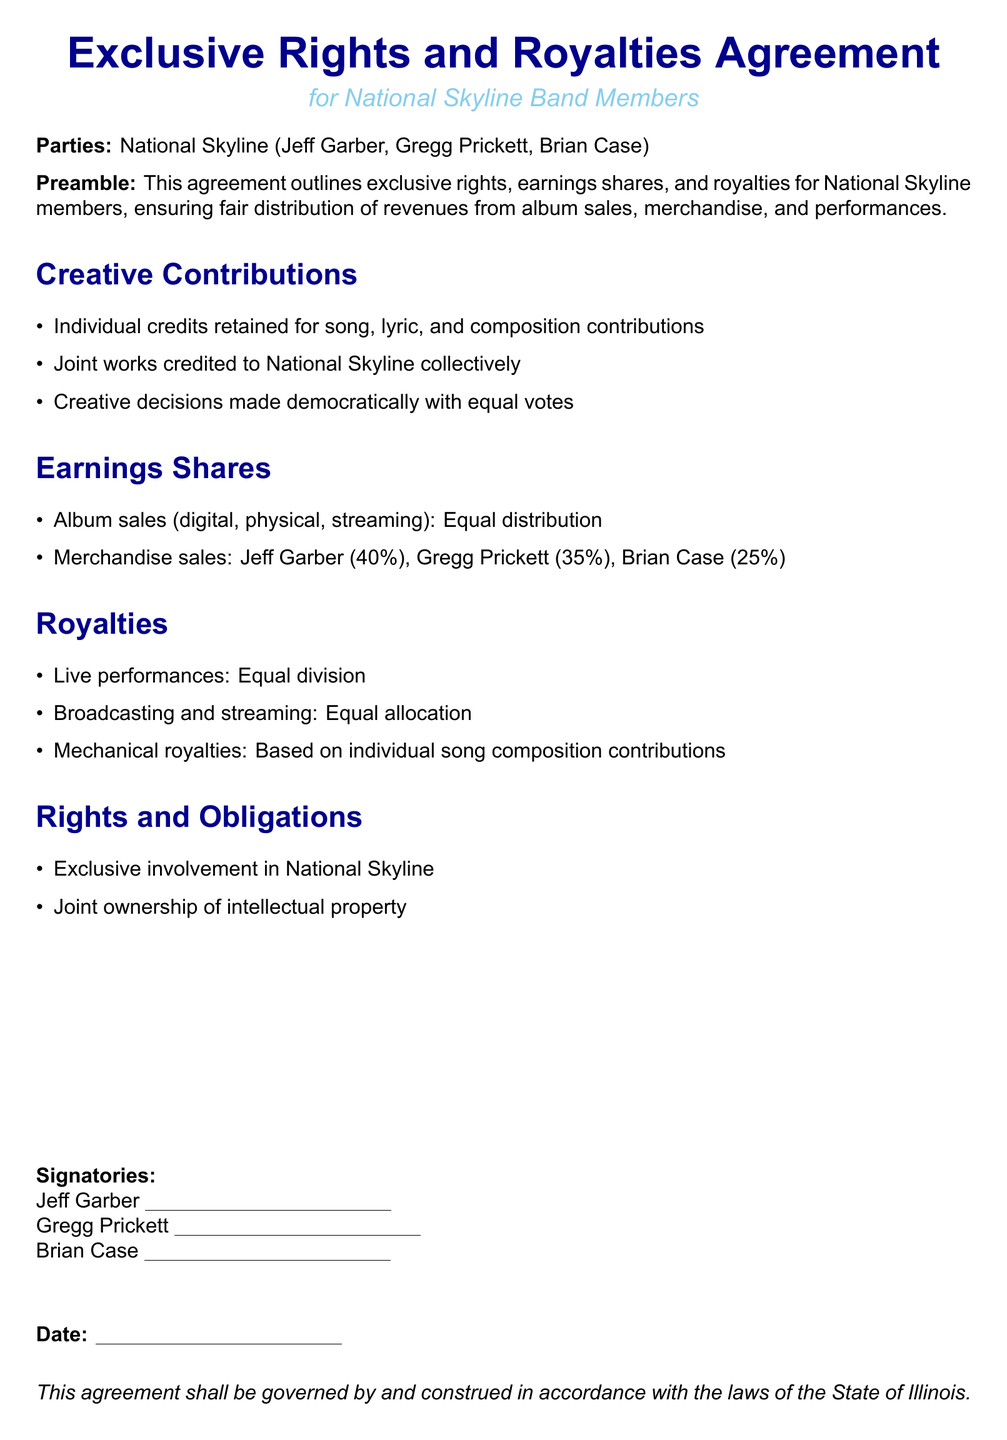What is the primary focus of the agreement? The agreement outlines exclusive rights, earnings shares, and royalties for National Skyline members.
Answer: exclusive rights, earnings shares, and royalties Who are the parties involved in the agreement? The parties involved are the members of National Skyline: Jeff Garber, Gregg Prickett, and Brian Case.
Answer: Jeff Garber, Gregg Prickett, Brian Case What percentage of merchandise sales does Jeff Garber receive? The document states the percentage distribution for merchandise sales, where Jeff Garber receives 40 percent.
Answer: 40% How are album sales earnings shared? Album sales are distributed equally among the members according to the document.
Answer: Equal distribution What governs this agreement? The agreement specifies that it shall be governed by and construed in accordance with the laws of a particular state.
Answer: State of Illinois How are live performance royalties shared? The document states that live performance royalties are divided equally among the band members.
Answer: Equal division What type of contributions are credited individually? The agreement specifies that individual credits are retained for specific types of contributions made by members.
Answer: song, lyric, and composition contributions What is required of the band members regarding their involvement? Members are required to maintain exclusive involvement in National Skyline.
Answer: Exclusive involvement What determines the distribution of mechanical royalties? The document specifies that mechanical royalties are distributed based on individual song contributions.
Answer: Based on individual song composition contributions 